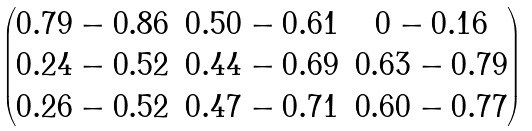Convert formula to latex. <formula><loc_0><loc_0><loc_500><loc_500>\begin{pmatrix} 0 . 7 9 - 0 . 8 6 & 0 . 5 0 - 0 . 6 1 & 0 - 0 . 1 6 \\ 0 . 2 4 - 0 . 5 2 & 0 . 4 4 - 0 . 6 9 & 0 . 6 3 - 0 . 7 9 \\ 0 . 2 6 - 0 . 5 2 & 0 . 4 7 - 0 . 7 1 & 0 . 6 0 - 0 . 7 7 \end{pmatrix}</formula> 